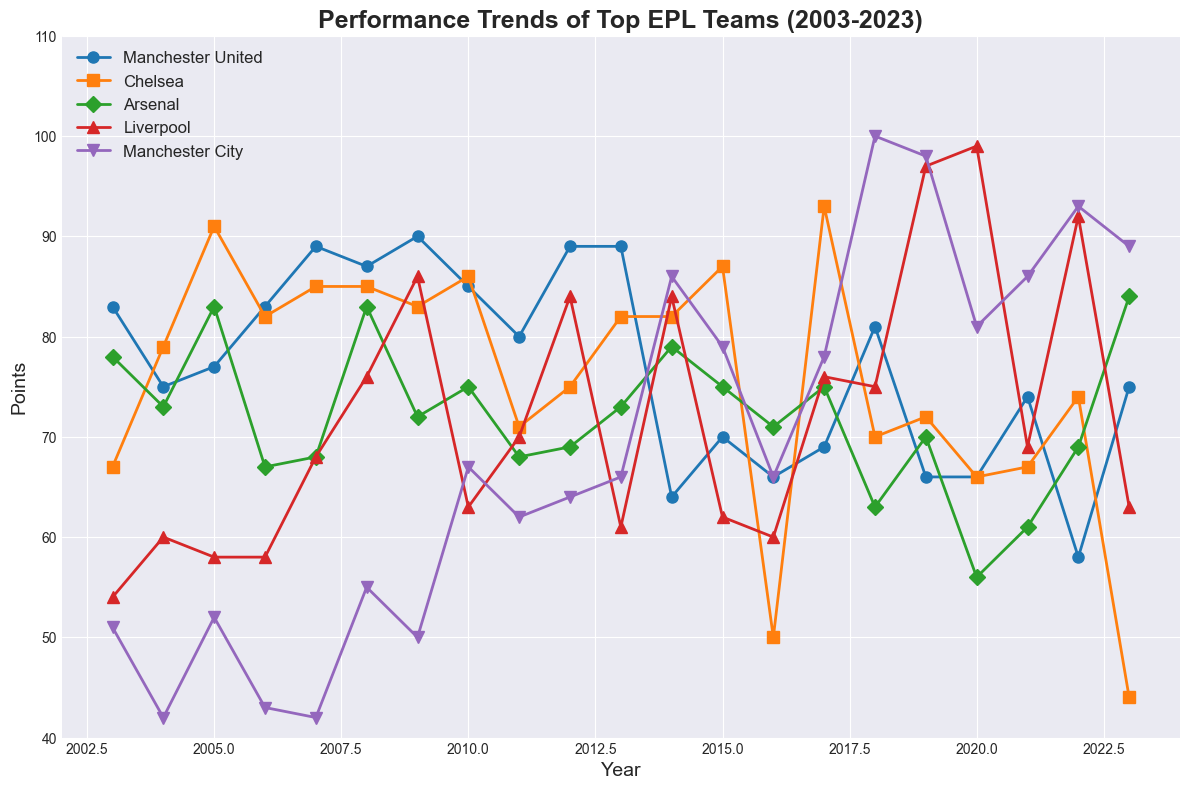what is the overall trend for Manchester City from 2003 to 2023? The line for Manchester City starts at 51 points in 2003 and shows a gradual upward trend, peaking at 100 points in 2018, before slightly decreasing and stabilizing around the 80-90 points mark towards 2023.
Answer: Upward trend with stabilization around 80-90 points in recent years Which team had the highest single-season point total and in which year? By looking at the peaks in the plot, Manchester City had the highest single-season point total with 100 points in 2018.
Answer: Manchester City in 2018 how did Arsenal's performance in 2023 compare to their performance in 2007? In the plot, Arsenal's points in 2023 are 84, while in 2007, they had 68. Comparing these values shows that Arsenal's performance in 2023 improved by 16 points compared to 2007.
Answer: Improved by 16 points Which team had the largest drop in points from one year to the next, and what were those years? The steepest drop can be seen for Chelsea between 2017 (93 points) and 2018 (70 points), a difference of 23 points.
Answer: Chelsea from 2017 to 2018 Which teams had relatively consistent performance without drastic changes in points over the twenty years? Both Manchester United and Arsenal show relatively smaller fluctuations compared to other teams, with Manchester United mostly hovering around 70-90 points and Arsenal mostly around 60-80 points.
Answer: Manchester United and Arsenal What year did Liverpool achieve almost 100 points, and how did their performance change the following year? Liverpool achieved 99 points in 2020. In the following year, 2021, their performance dropped to 69 points, showing a decrease of 30 points.
Answer: 2020, decreased by 30 points During which year did Manchester United experience their lowest recorded performance? Manchester United's lowest point total on the plot is 58 in 2022.
Answer: 2022 Between which years did Chelsea experience their longest period of increasing points? Chelsea's data show a steady increase from 2001's 67 points to 2007's 85 points, a span of six years.
Answer: 2003-2007 How many times did Arsenal score above 70 points in the plot? From the plot, Arsenal scored above 70 points in 2003, 2005, 2010, 2014, 2015, 2017, and 2023, summing up to 7 times.
Answer: 7 times 